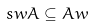Convert formula to latex. <formula><loc_0><loc_0><loc_500><loc_500>s w A \subseteq A w</formula> 